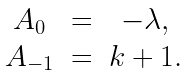Convert formula to latex. <formula><loc_0><loc_0><loc_500><loc_500>\begin{array} { c c c } A _ { 0 } & = & - \lambda , \\ A _ { - 1 } & = & k + 1 . \end{array}</formula> 